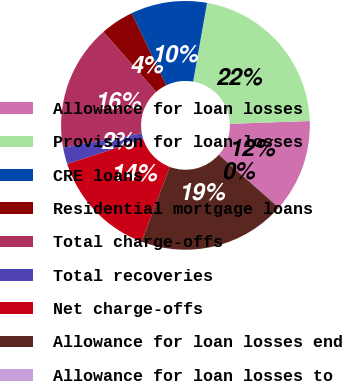Convert chart. <chart><loc_0><loc_0><loc_500><loc_500><pie_chart><fcel>Allowance for loan losses<fcel>Provision for loan losses<fcel>CRE loans<fcel>Residential mortgage loans<fcel>Total charge-offs<fcel>Total recoveries<fcel>Net charge-offs<fcel>Allowance for loan losses end<fcel>Allowance for loan losses to<nl><fcel>12.06%<fcel>21.67%<fcel>9.9%<fcel>4.34%<fcel>16.4%<fcel>2.17%<fcel>14.23%<fcel>19.23%<fcel>0.0%<nl></chart> 